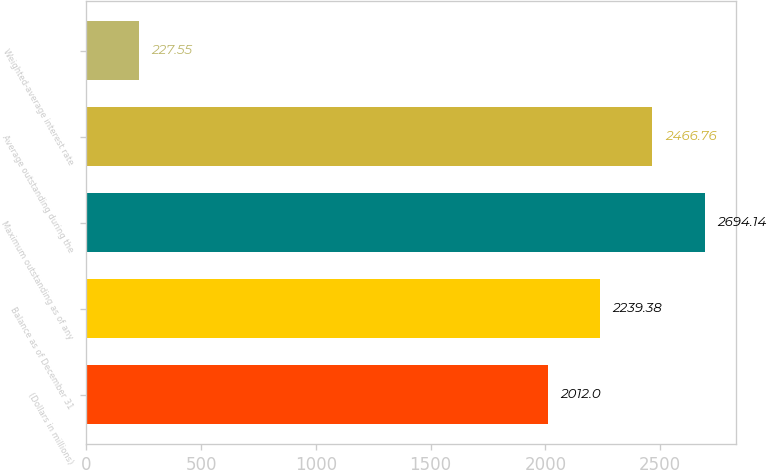<chart> <loc_0><loc_0><loc_500><loc_500><bar_chart><fcel>(Dollars in millions)<fcel>Balance as of December 31<fcel>Maximum outstanding as of any<fcel>Average outstanding during the<fcel>Weighted-average interest rate<nl><fcel>2012<fcel>2239.38<fcel>2694.14<fcel>2466.76<fcel>227.55<nl></chart> 